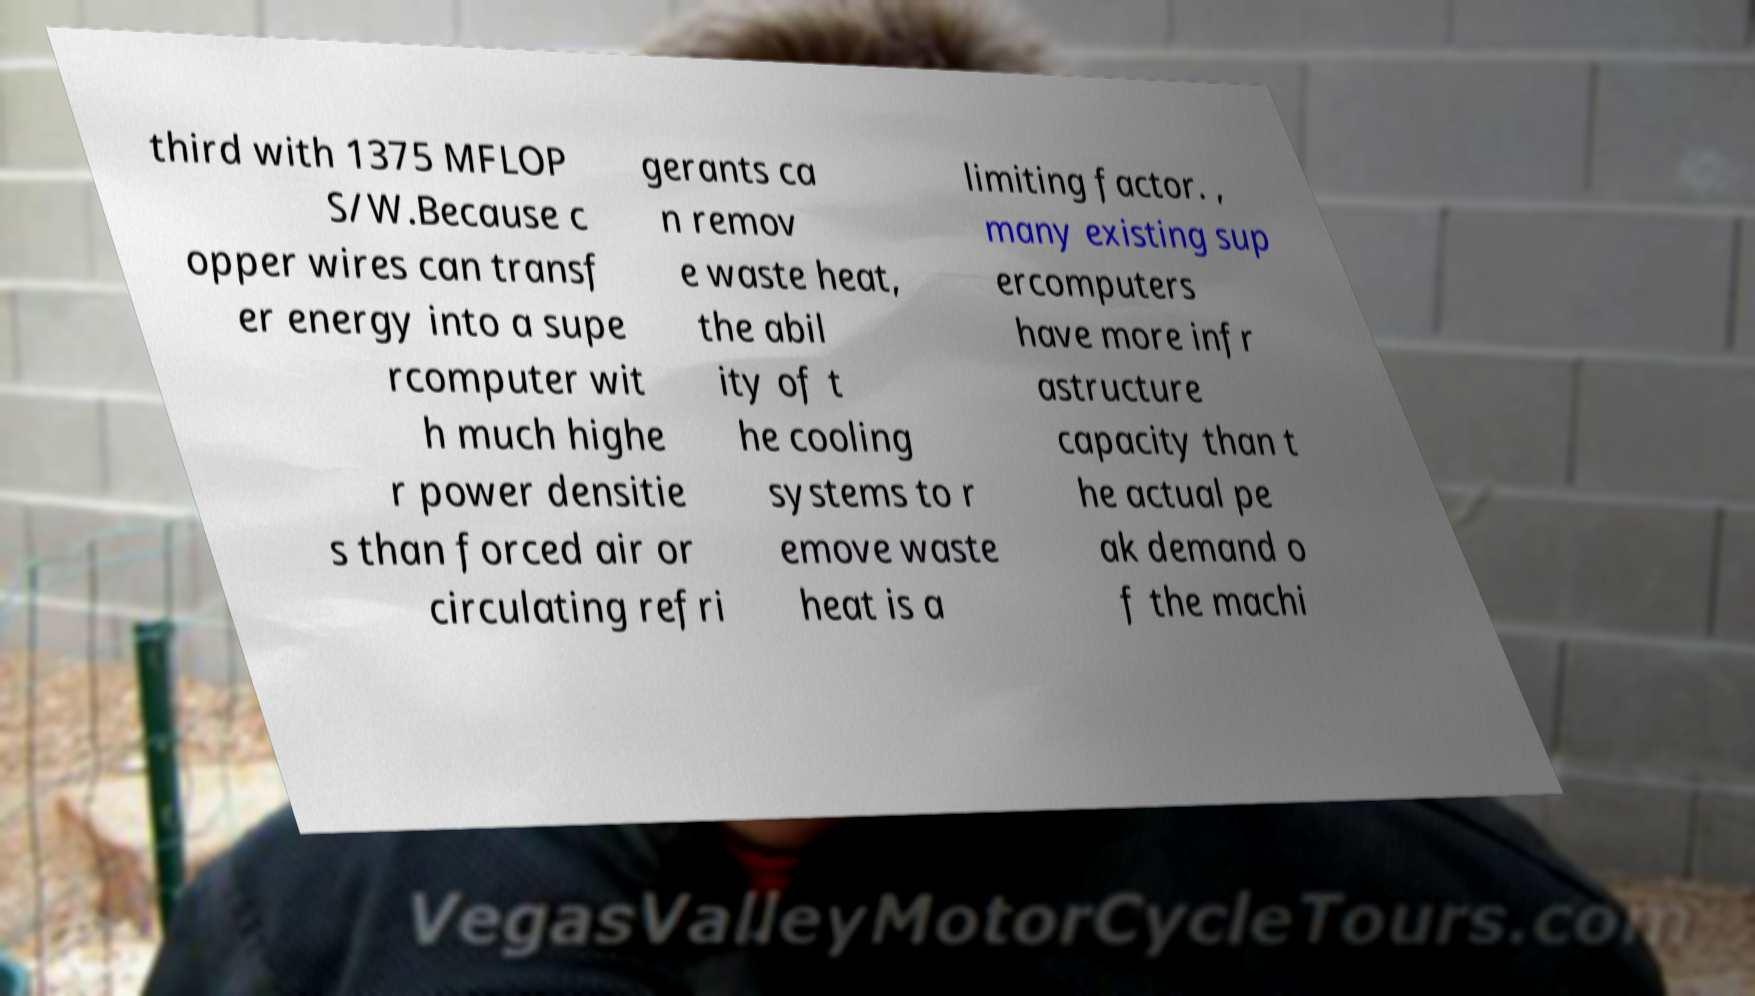Can you read and provide the text displayed in the image?This photo seems to have some interesting text. Can you extract and type it out for me? third with 1375 MFLOP S/W.Because c opper wires can transf er energy into a supe rcomputer wit h much highe r power densitie s than forced air or circulating refri gerants ca n remov e waste heat, the abil ity of t he cooling systems to r emove waste heat is a limiting factor. , many existing sup ercomputers have more infr astructure capacity than t he actual pe ak demand o f the machi 